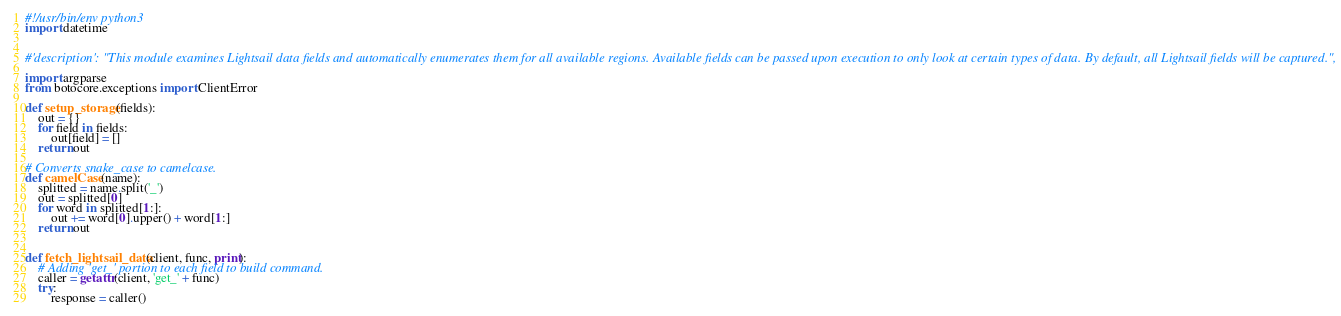<code> <loc_0><loc_0><loc_500><loc_500><_Python_>#!/usr/bin/env python3
import datetime


#'description': "This module examines Lightsail data fields and automatically enumerates them for all available regions. Available fields can be passed upon execution to only look at certain types of data. By default, all Lightsail fields will be captured.",

import argparse
from botocore.exceptions import ClientError

def setup_storage(fields):
    out = {}
    for field in fields:
        out[field] = []
    return out

# Converts snake_case to camelcase.
def camelCase(name):
    splitted = name.split('_')
    out = splitted[0]
    for word in splitted[1:]:
        out += word[0].upper() + word[1:]
    return out


def fetch_lightsail_data(client, func, print):
    # Adding 'get_' portion to each field to build command.
    caller = getattr(client, 'get_' + func)
    try:
        response = caller()</code> 